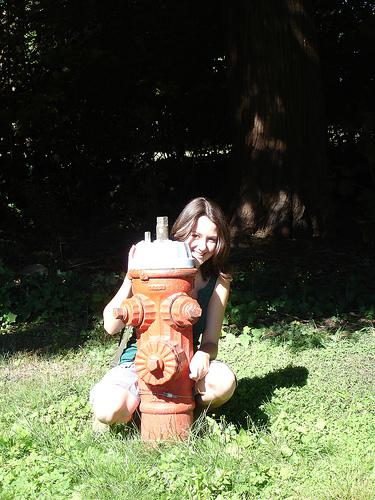Question: how is the girl sitting with the fire hydrant?
Choices:
A. She is squatting.
B. On the ground.
C. Leaning on the hydrant.
D. Sitting on top of the hydrant.
Answer with the letter. Answer: A Question: what is on the ground?
Choices:
A. Grass.
B. Dirt.
C. Flowers.
D. Bugs.
Answer with the letter. Answer: A Question: what is behind the girl?
Choices:
A. A bush.
B. A tree.
C. A river.
D. An arbor.
Answer with the letter. Answer: B Question: where is the fire hydrant?
Choices:
A. In the left side of the picture.
B. In the center of the picture.
C. In the right side of the picture.
D. In the corner of the picture.
Answer with the letter. Answer: B 